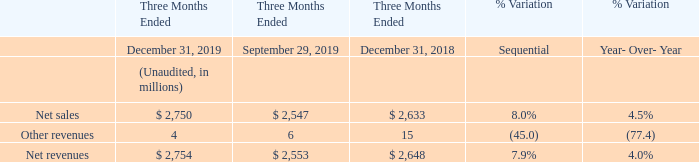Our fourth quarter 2019 net revenues amounted to $2,754 million, registering a sequential increase of 7.9%, 290 basis points above the mid-point of our guidance, with all product groups contributing to the growth. The sequential increase resulted from higher volumes of approximately 7% and an increase of approximately 1% in average selling prices, the latter entirely due to product mix, while selling prices remained substantially stable.
On a year-over-year basis, our net revenues increased by 4.0%. This increase was entirely due to an increase of approximately 6% in average selling prices, partially offset by an approximate 2% decrease in volumes. The average selling prices increase was entirely driven by improved product mix of approximately 9%, partially offset by lower selling prices of approximately 3%.
What led to sequential increase in 2019? Resulted from higher volumes of approximately 7% and an increase of approximately 1% in average selling prices, the latter entirely due to product mix, while selling prices remained substantially stable. What led to increase in net revenues On a year-over-year basis? Due to an increase of approximately 6% in average selling prices, partially offset by an approximate 2% decrease in volumes. What led to increase in average selling price on a year-over-year basis? Driven by improved product mix of approximately 9%, partially offset by lower selling prices of approximately 3%. What is the average Net sales for the period December 31, 2019 and 2018?
Answer scale should be: million. (2,750+2,633) / 2
Answer: 2691.5. What is the average other revenues sales for the period December 31, 2019 and 2018?
Answer scale should be: million. (4+15) / 2
Answer: 9.5. What is the average net revenues for the period December 31, 2019 and 2018?
Answer scale should be: million. (2,754+2,648) / 2
Answer: 2701. 